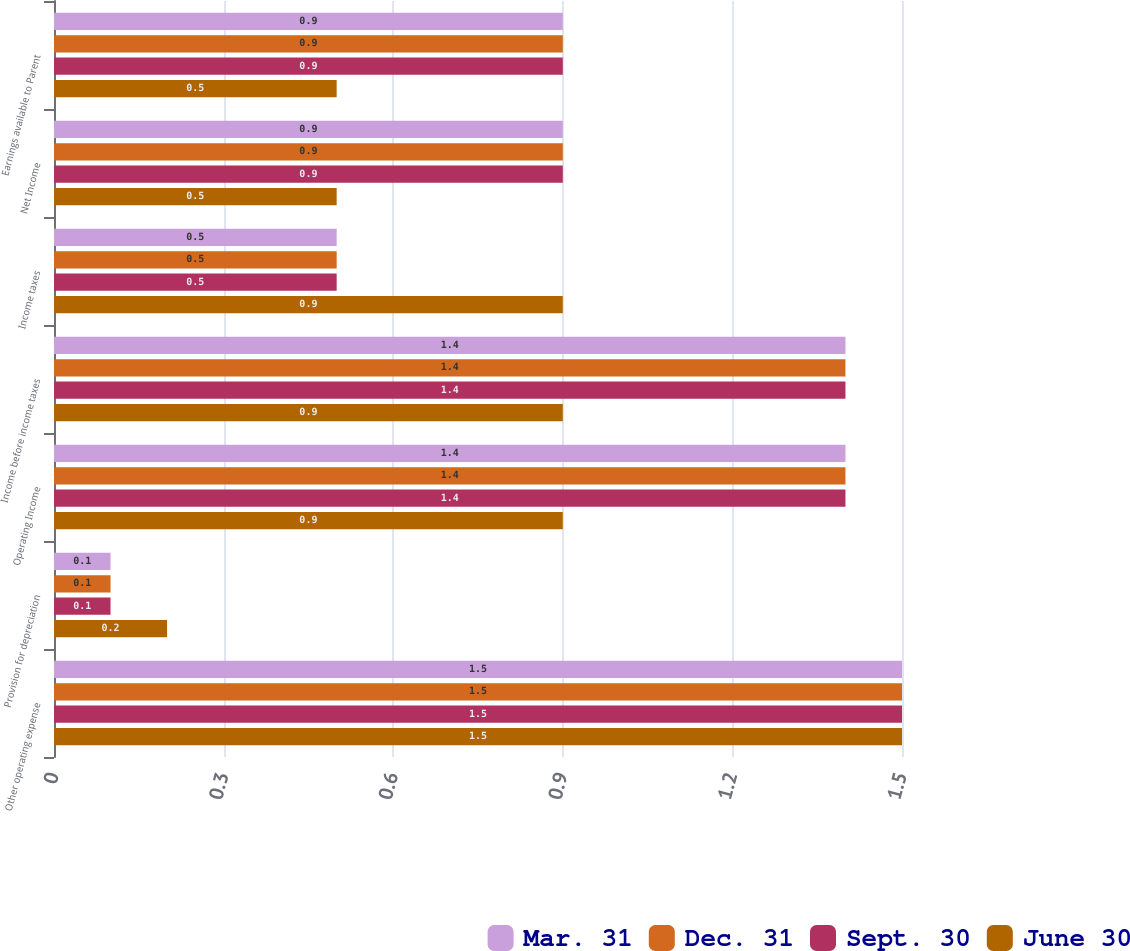<chart> <loc_0><loc_0><loc_500><loc_500><stacked_bar_chart><ecel><fcel>Other operating expense<fcel>Provision for depreciation<fcel>Operating Income<fcel>Income before income taxes<fcel>Income taxes<fcel>Net Income<fcel>Earnings available to Parent<nl><fcel>Mar. 31<fcel>1.5<fcel>0.1<fcel>1.4<fcel>1.4<fcel>0.5<fcel>0.9<fcel>0.9<nl><fcel>Dec. 31<fcel>1.5<fcel>0.1<fcel>1.4<fcel>1.4<fcel>0.5<fcel>0.9<fcel>0.9<nl><fcel>Sept. 30<fcel>1.5<fcel>0.1<fcel>1.4<fcel>1.4<fcel>0.5<fcel>0.9<fcel>0.9<nl><fcel>June 30<fcel>1.5<fcel>0.2<fcel>0.9<fcel>0.9<fcel>0.9<fcel>0.5<fcel>0.5<nl></chart> 